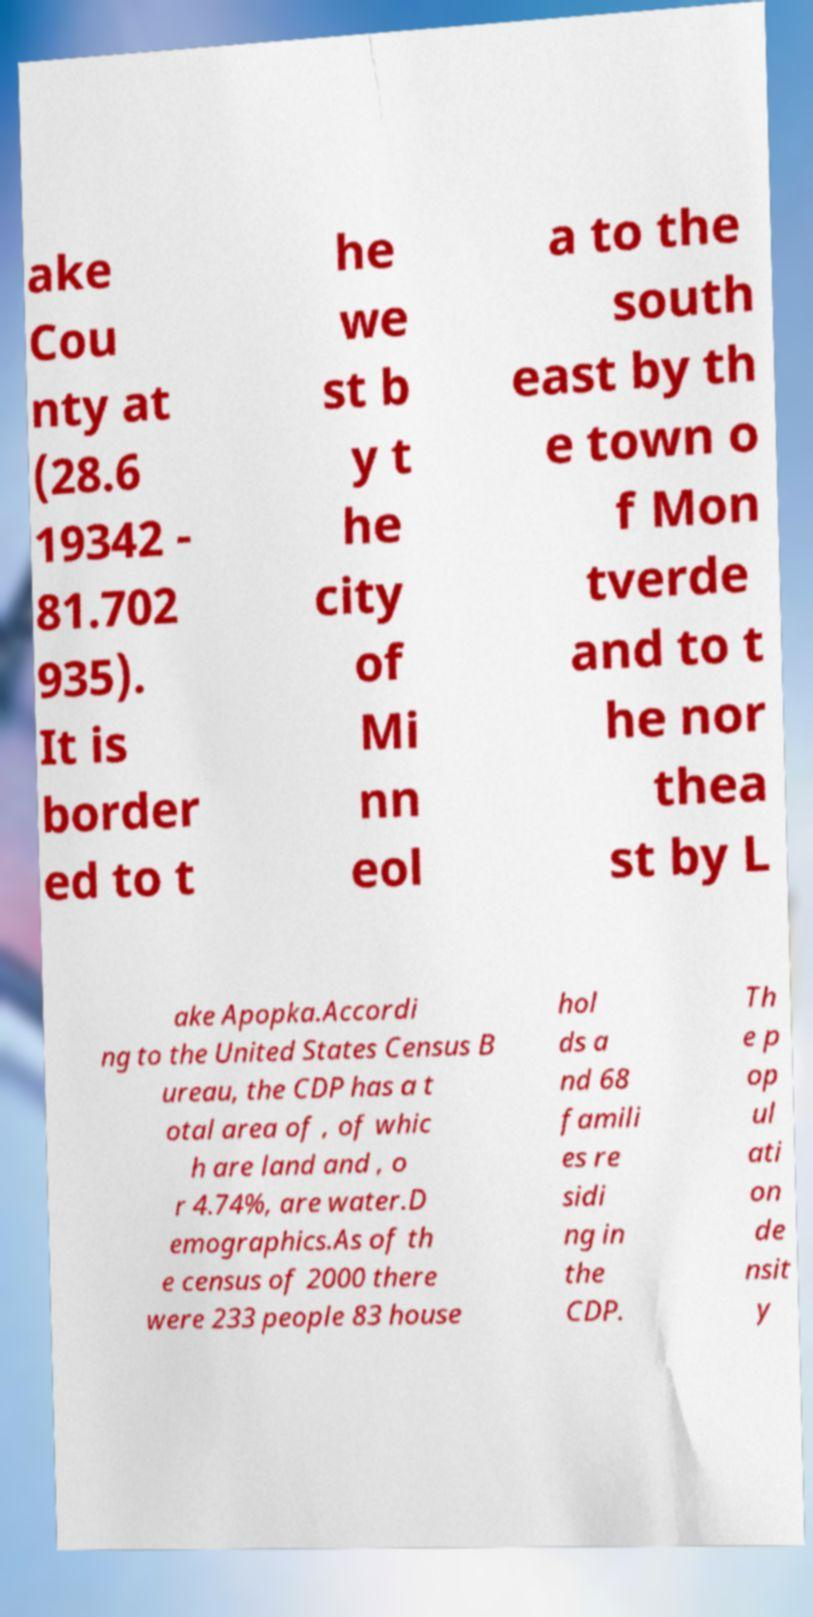Can you accurately transcribe the text from the provided image for me? ake Cou nty at (28.6 19342 - 81.702 935). It is border ed to t he we st b y t he city of Mi nn eol a to the south east by th e town o f Mon tverde and to t he nor thea st by L ake Apopka.Accordi ng to the United States Census B ureau, the CDP has a t otal area of , of whic h are land and , o r 4.74%, are water.D emographics.As of th e census of 2000 there were 233 people 83 house hol ds a nd 68 famili es re sidi ng in the CDP. Th e p op ul ati on de nsit y 